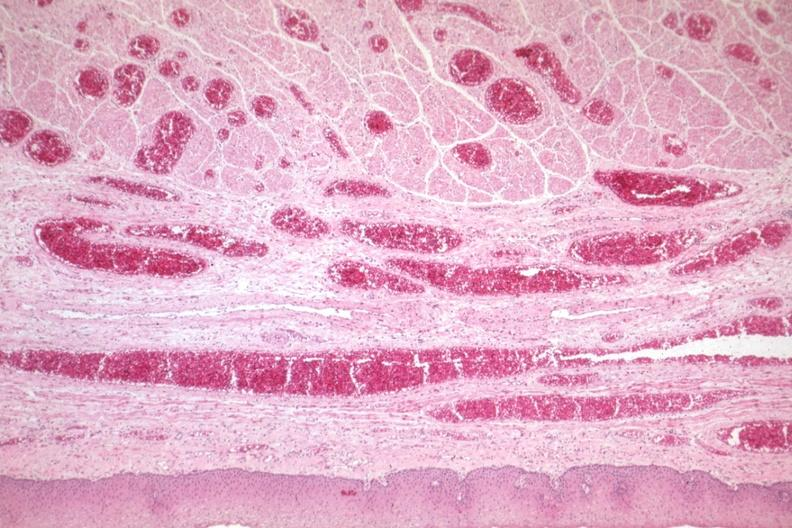s ml present?
Answer the question using a single word or phrase. No 